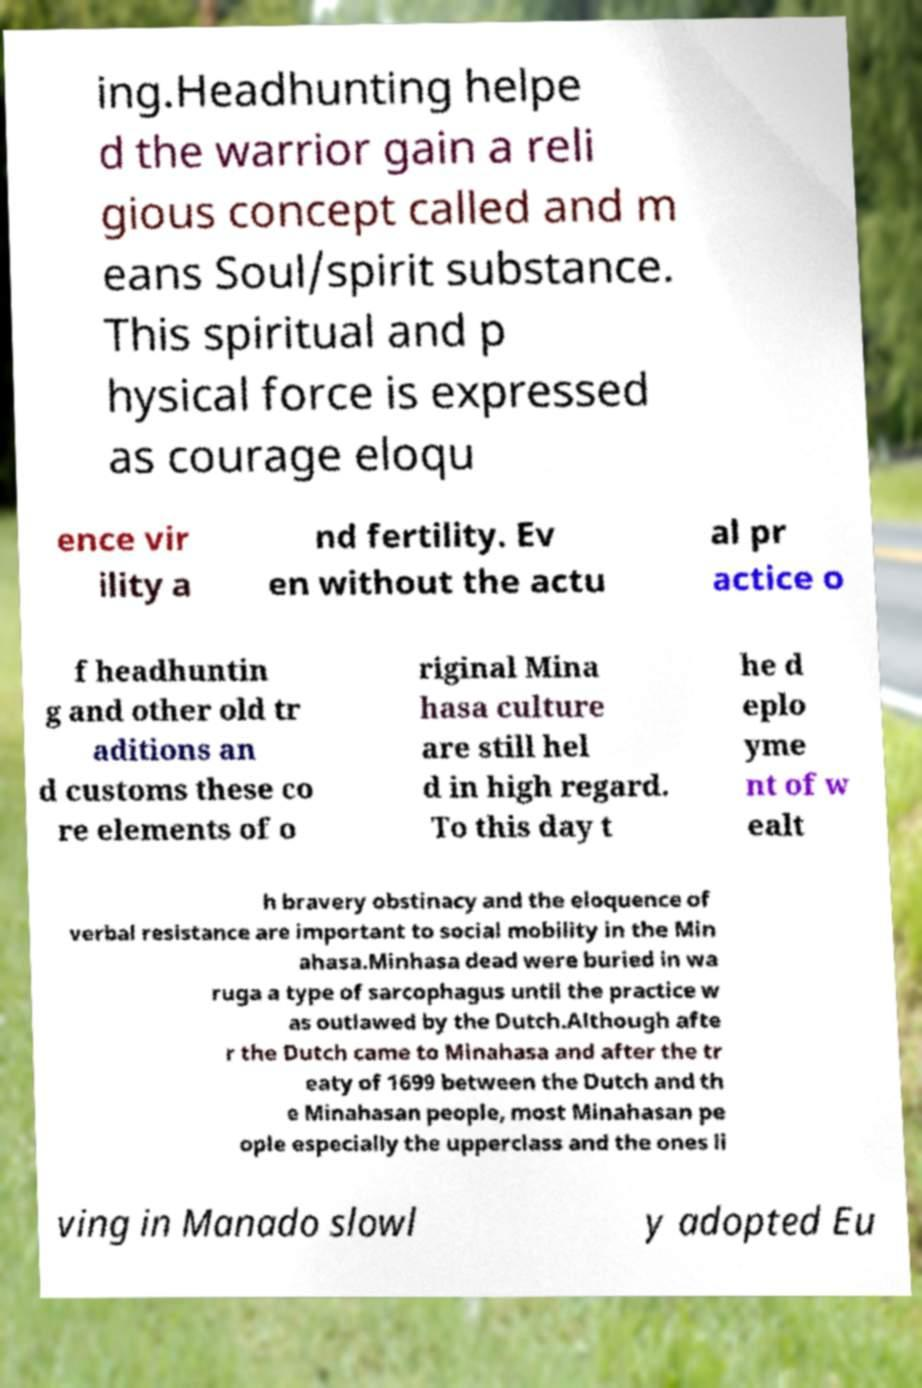Please identify and transcribe the text found in this image. ing.Headhunting helpe d the warrior gain a reli gious concept called and m eans Soul/spirit substance. This spiritual and p hysical force is expressed as courage eloqu ence vir ility a nd fertility. Ev en without the actu al pr actice o f headhuntin g and other old tr aditions an d customs these co re elements of o riginal Mina hasa culture are still hel d in high regard. To this day t he d eplo yme nt of w ealt h bravery obstinacy and the eloquence of verbal resistance are important to social mobility in the Min ahasa.Minhasa dead were buried in wa ruga a type of sarcophagus until the practice w as outlawed by the Dutch.Although afte r the Dutch came to Minahasa and after the tr eaty of 1699 between the Dutch and th e Minahasan people, most Minahasan pe ople especially the upperclass and the ones li ving in Manado slowl y adopted Eu 